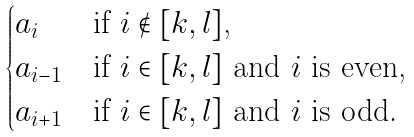<formula> <loc_0><loc_0><loc_500><loc_500>\begin{cases} a _ { i } & \text {if $i \notin [k,l]$,} \\ a _ { i - 1 } & \text {if $i \in [k,l]$ and $i$ is even,} \\ a _ { i + 1 } & \text {if $i \in [k,l]$ and $i$ is odd.} \end{cases}</formula> 